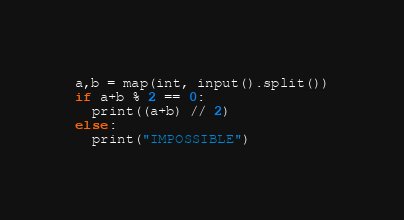<code> <loc_0><loc_0><loc_500><loc_500><_Python_>a,b = map(int, input().split())
if a+b % 2 == 0:
  print((a+b) // 2)
else:
  print("IMPOSSIBLE")
</code> 